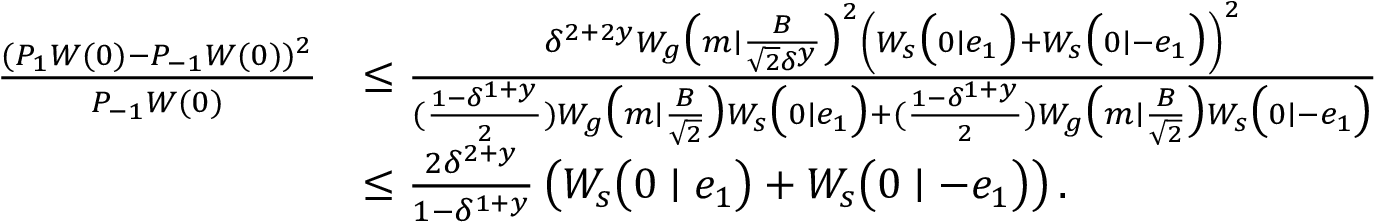Convert formula to latex. <formula><loc_0><loc_0><loc_500><loc_500>\begin{array} { r l } { \frac { ( P _ { 1 } W ( 0 ) - P _ { - 1 } W ( 0 ) ) ^ { 2 } } { P _ { - 1 } W ( 0 ) } } & { \leq \frac { \delta ^ { 2 + 2 y } W _ { g } \left ( m | \frac { B } { \sqrt { 2 } \delta ^ { y } } \right ) ^ { 2 } \left ( W _ { s } \left ( 0 | e _ { 1 } \right ) + W _ { s } \left ( 0 | - e _ { 1 } \right ) \right ) ^ { 2 } } { ( \frac { 1 - \delta ^ { 1 + y } } { 2 } ) W _ { g } \left ( m | \frac { B } { \sqrt { 2 } } \right ) W _ { s } \left ( 0 | e _ { 1 } \right ) + ( \frac { 1 - \delta ^ { 1 + y } } { 2 } ) W _ { g } \left ( m | \frac { B } { \sqrt { 2 } } \right ) W _ { s } \left ( 0 | - e _ { 1 } \right ) } } \\ & { \leq \frac { 2 \delta ^ { 2 + y } } { 1 - \delta ^ { 1 + y } } \left ( W _ { s } \left ( 0 | e _ { 1 } \right ) + W _ { s } \left ( 0 | - e _ { 1 } \right ) \right ) . } \end{array}</formula> 